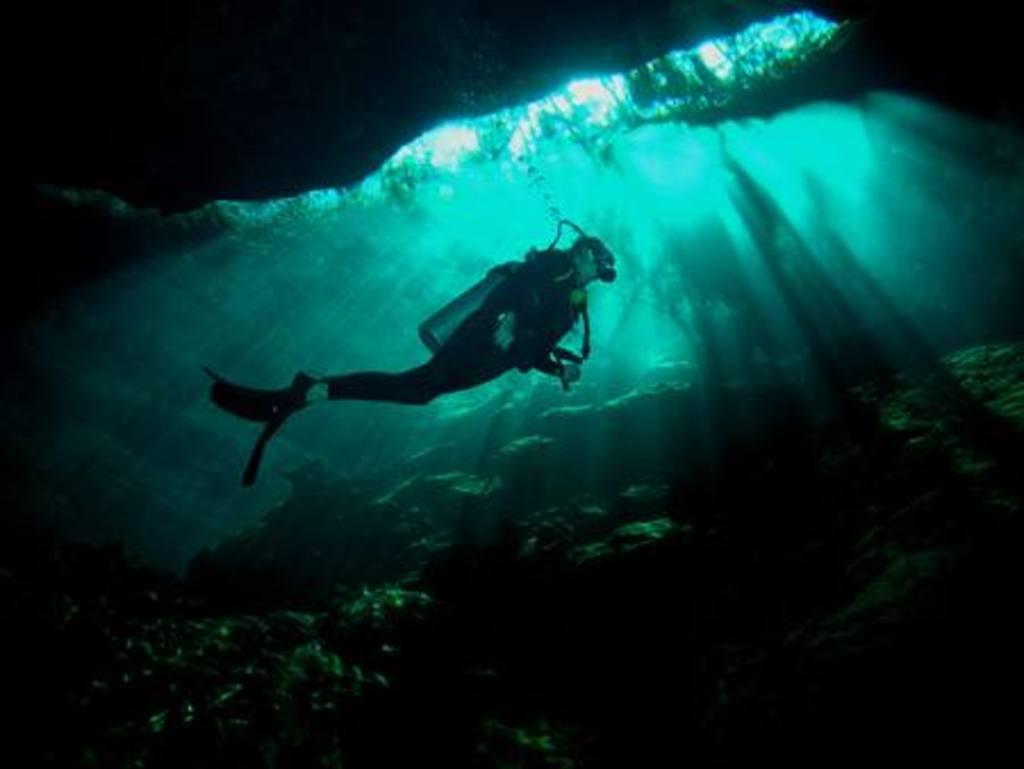In one or two sentences, can you explain what this image depicts? In this image we can see a person swimming in water, wearing swimsuit and oxygen mask. At the bottom of the image there are stones. 